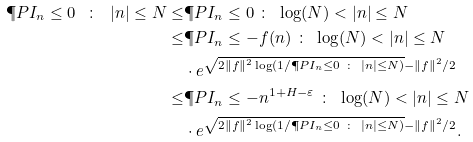<formula> <loc_0><loc_0><loc_500><loc_500>\P P { I _ { n } \leq 0 \ \colon \ | n | \leq N } \leq & \P P { I _ { n } \leq 0 \ \colon \ \log ( N ) < | n | \leq N } \\ \leq & \P P { I _ { n } \leq - f ( n ) \ \colon \ \log ( N ) < | n | \leq N } \\ & \cdot e ^ { \sqrt { 2 \| f \| ^ { 2 } \log ( 1 / \P P { I _ { n } \leq 0 \ \colon \ | n | \leq N } ) } - \| f \| ^ { 2 } / 2 } \\ \leq & \P P { I _ { n } \leq - n ^ { 1 + H - \varepsilon } \ \colon \ \log ( N ) < | n | \leq N } \\ & \cdot e ^ { \sqrt { 2 \| f \| ^ { 2 } \log ( 1 / \P P { I _ { n } \leq 0 \ \colon \ | n | \leq N } ) } - \| f \| ^ { 2 } / 2 } .</formula> 